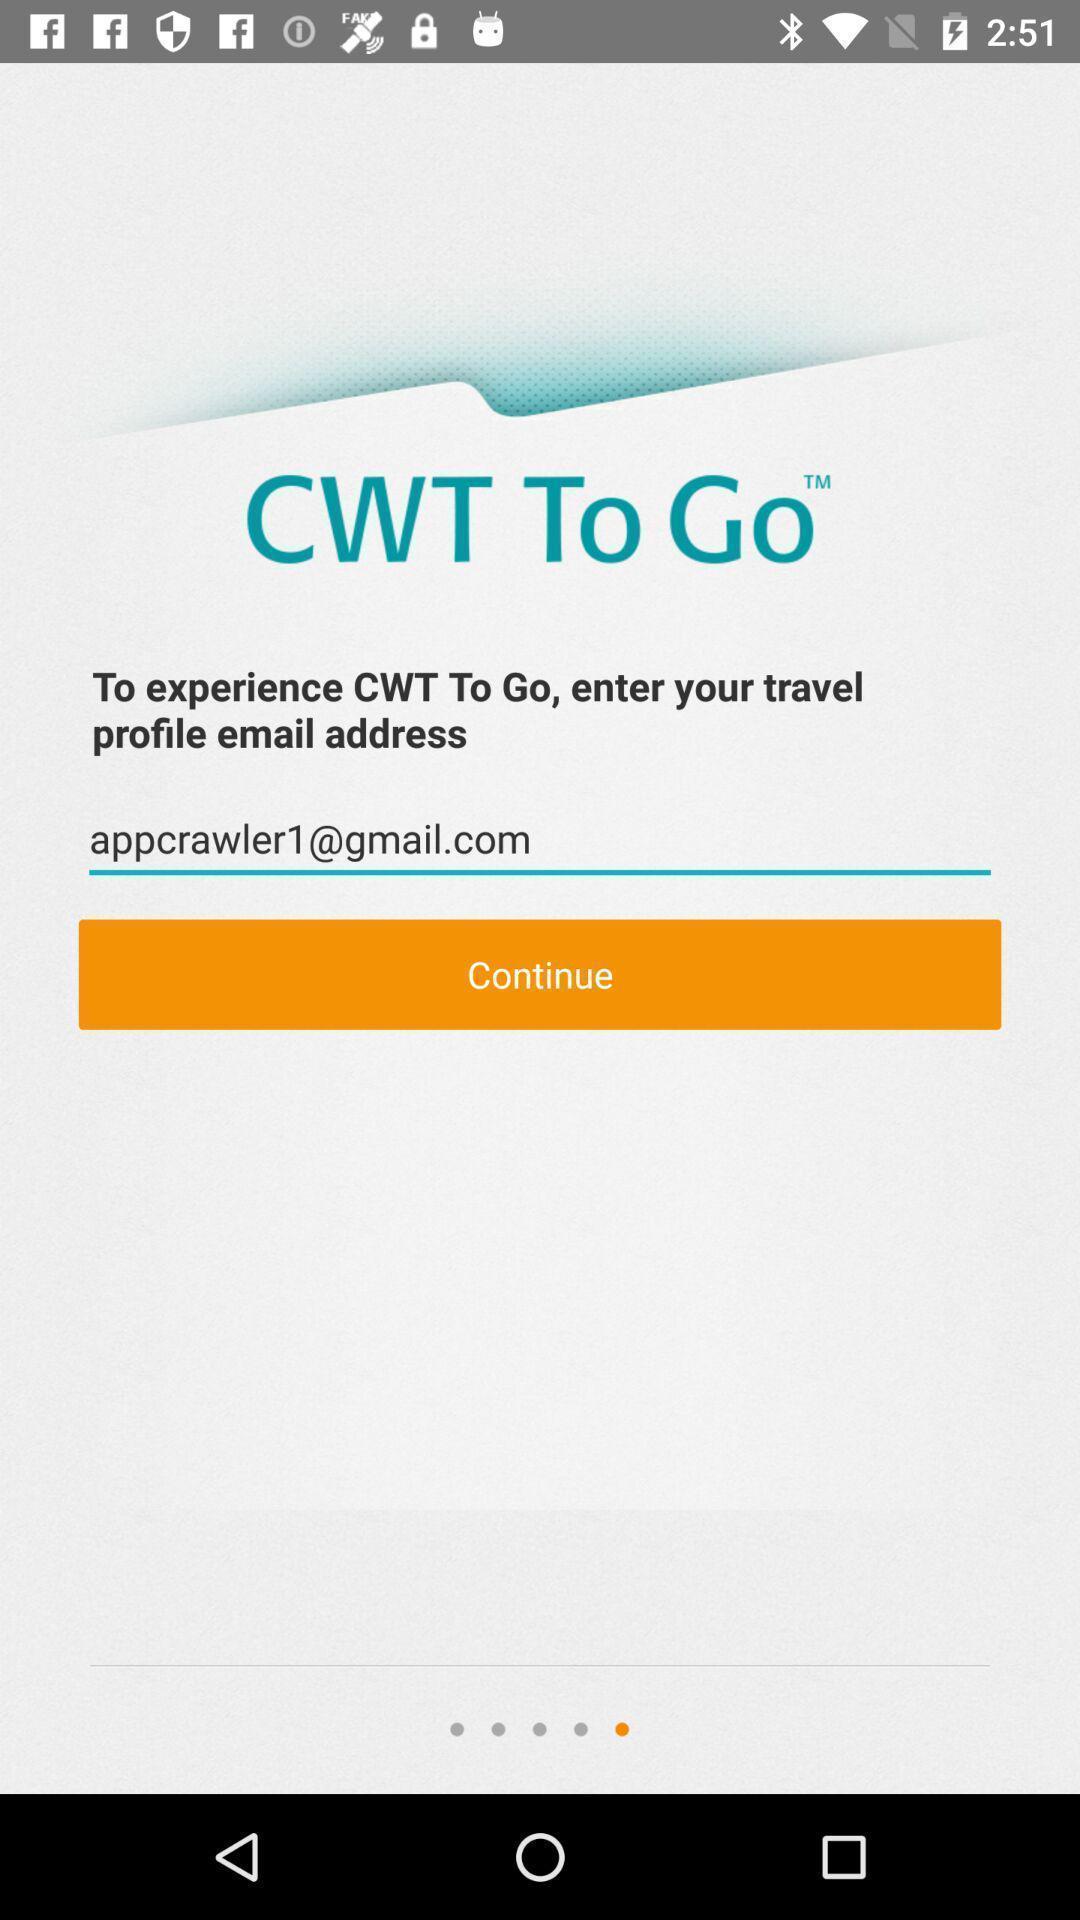What can you discern from this picture? Welcome page of a travel application. 